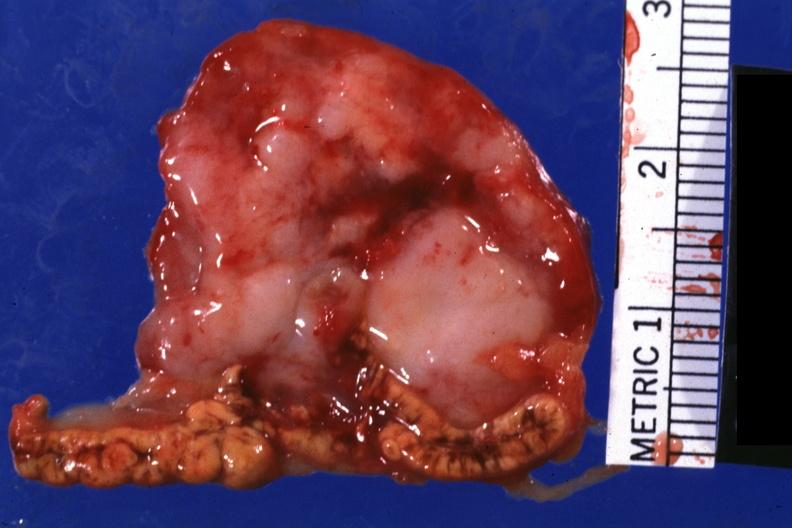s intraductal papillomatosis with apocrine metaplasia present?
Answer the question using a single word or phrase. No 